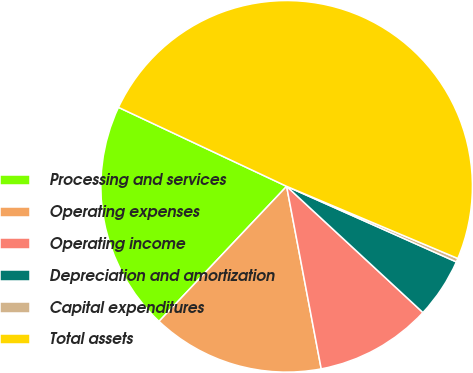Convert chart. <chart><loc_0><loc_0><loc_500><loc_500><pie_chart><fcel>Processing and services<fcel>Operating expenses<fcel>Operating income<fcel>Depreciation and amortization<fcel>Capital expenditures<fcel>Total assets<nl><fcel>19.94%<fcel>15.03%<fcel>10.13%<fcel>5.22%<fcel>0.32%<fcel>49.36%<nl></chart> 